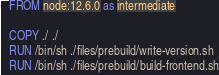Convert code to text. <code><loc_0><loc_0><loc_500><loc_500><_Dockerfile_>FROM node:12.6.0 as intermediate

COPY ./ ./
RUN /bin/sh ./files/prebuild/write-version.sh
RUN /bin/sh ./files/prebuild/build-frontend.sh

</code> 